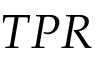Convert formula to latex. <formula><loc_0><loc_0><loc_500><loc_500>T P R</formula> 